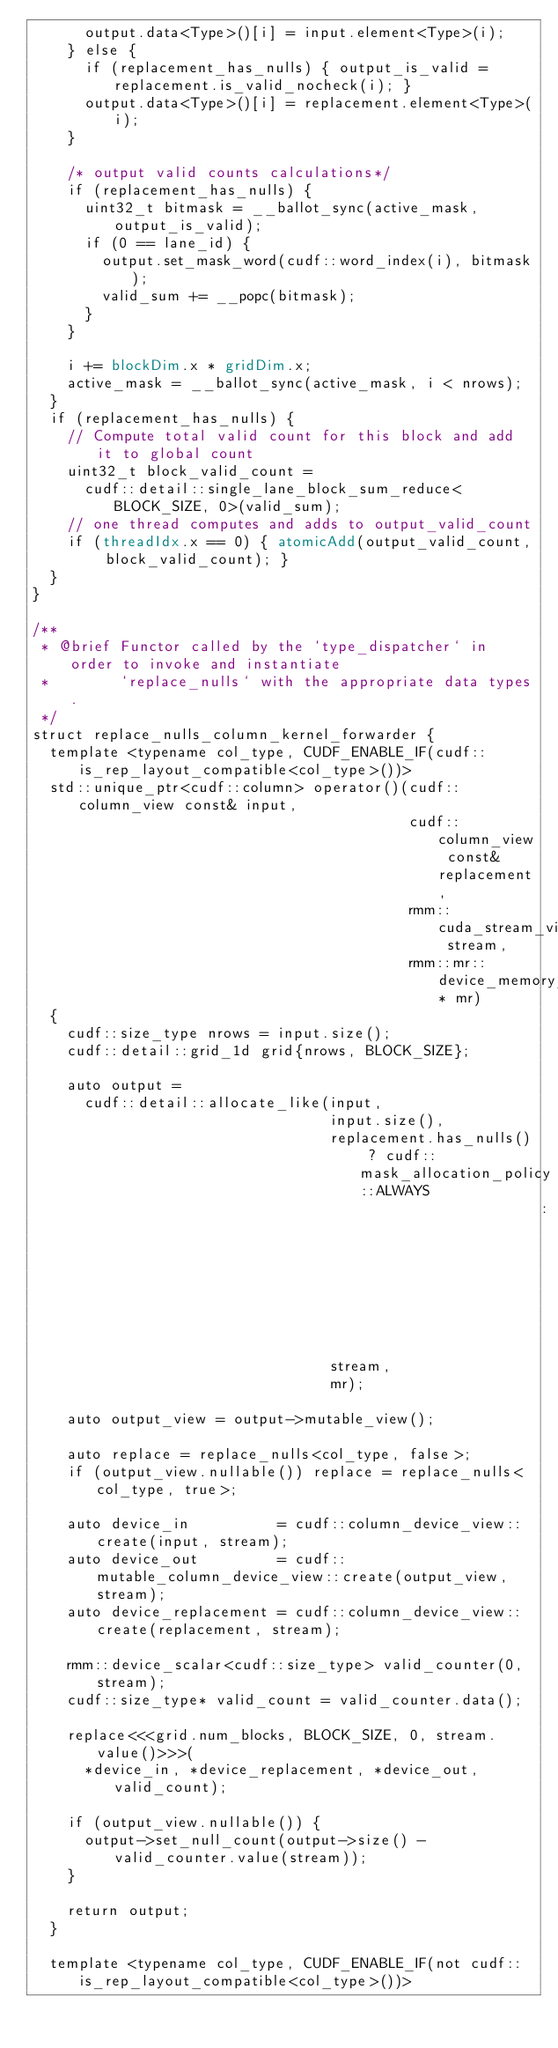<code> <loc_0><loc_0><loc_500><loc_500><_Cuda_>      output.data<Type>()[i] = input.element<Type>(i);
    } else {
      if (replacement_has_nulls) { output_is_valid = replacement.is_valid_nocheck(i); }
      output.data<Type>()[i] = replacement.element<Type>(i);
    }

    /* output valid counts calculations*/
    if (replacement_has_nulls) {
      uint32_t bitmask = __ballot_sync(active_mask, output_is_valid);
      if (0 == lane_id) {
        output.set_mask_word(cudf::word_index(i), bitmask);
        valid_sum += __popc(bitmask);
      }
    }

    i += blockDim.x * gridDim.x;
    active_mask = __ballot_sync(active_mask, i < nrows);
  }
  if (replacement_has_nulls) {
    // Compute total valid count for this block and add it to global count
    uint32_t block_valid_count =
      cudf::detail::single_lane_block_sum_reduce<BLOCK_SIZE, 0>(valid_sum);
    // one thread computes and adds to output_valid_count
    if (threadIdx.x == 0) { atomicAdd(output_valid_count, block_valid_count); }
  }
}

/**
 * @brief Functor called by the `type_dispatcher` in order to invoke and instantiate
 *        `replace_nulls` with the appropriate data types.
 */
struct replace_nulls_column_kernel_forwarder {
  template <typename col_type, CUDF_ENABLE_IF(cudf::is_rep_layout_compatible<col_type>())>
  std::unique_ptr<cudf::column> operator()(cudf::column_view const& input,
                                           cudf::column_view const& replacement,
                                           rmm::cuda_stream_view stream,
                                           rmm::mr::device_memory_resource* mr)
  {
    cudf::size_type nrows = input.size();
    cudf::detail::grid_1d grid{nrows, BLOCK_SIZE};

    auto output =
      cudf::detail::allocate_like(input,
                                  input.size(),
                                  replacement.has_nulls() ? cudf::mask_allocation_policy::ALWAYS
                                                          : cudf::mask_allocation_policy::NEVER,
                                  stream,
                                  mr);

    auto output_view = output->mutable_view();

    auto replace = replace_nulls<col_type, false>;
    if (output_view.nullable()) replace = replace_nulls<col_type, true>;

    auto device_in          = cudf::column_device_view::create(input, stream);
    auto device_out         = cudf::mutable_column_device_view::create(output_view, stream);
    auto device_replacement = cudf::column_device_view::create(replacement, stream);

    rmm::device_scalar<cudf::size_type> valid_counter(0, stream);
    cudf::size_type* valid_count = valid_counter.data();

    replace<<<grid.num_blocks, BLOCK_SIZE, 0, stream.value()>>>(
      *device_in, *device_replacement, *device_out, valid_count);

    if (output_view.nullable()) {
      output->set_null_count(output->size() - valid_counter.value(stream));
    }

    return output;
  }

  template <typename col_type, CUDF_ENABLE_IF(not cudf::is_rep_layout_compatible<col_type>())></code> 